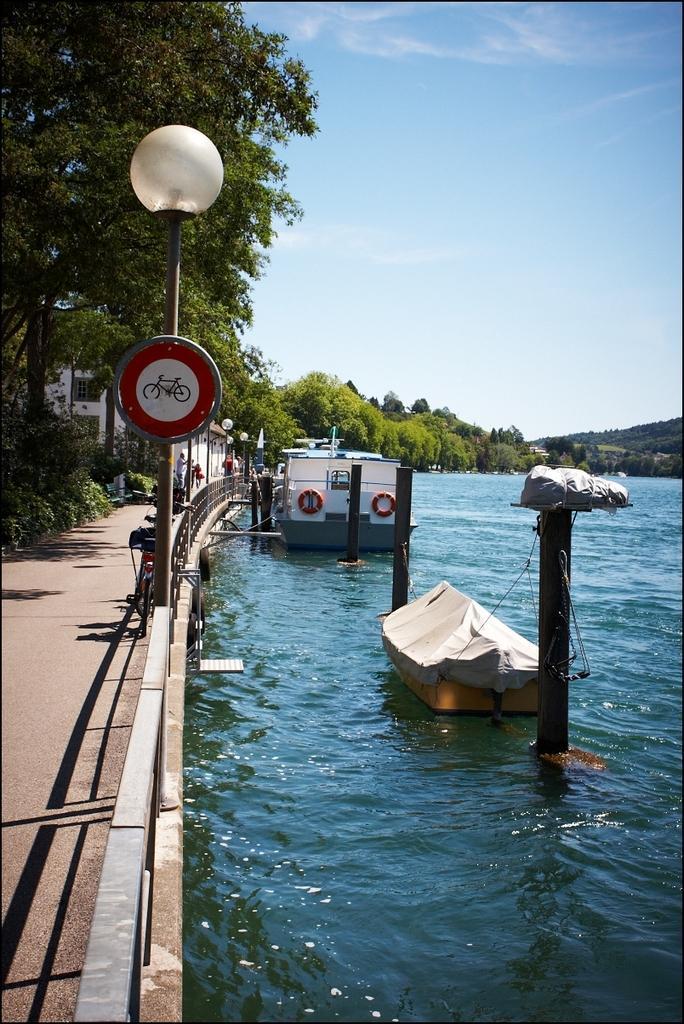Can you describe this image briefly? In this picture we can see the boats on the water. On the left we can see wooden fencing, street lights, sign board and bench. On the left background there is a building near to the trees. In the background we can see the mountain, trees and river. At the top we can see sky and clouds. 